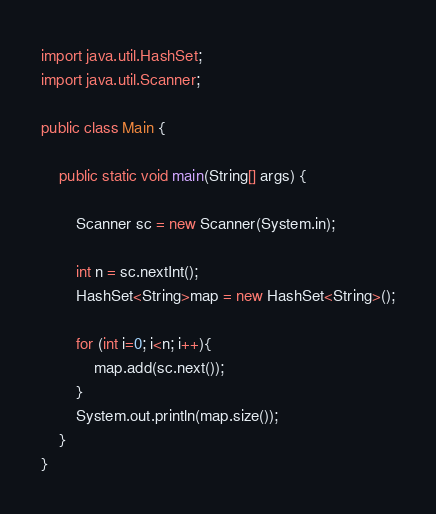Convert code to text. <code><loc_0><loc_0><loc_500><loc_500><_Java_>import java.util.HashSet;
import java.util.Scanner;

public class Main {

	public static void main(String[] args) {

		Scanner sc = new Scanner(System.in);

		int n = sc.nextInt();
		HashSet<String>map = new HashSet<String>();

		for (int i=0; i<n; i++){
			map.add(sc.next());
		}
		System.out.println(map.size());
	}
}</code> 